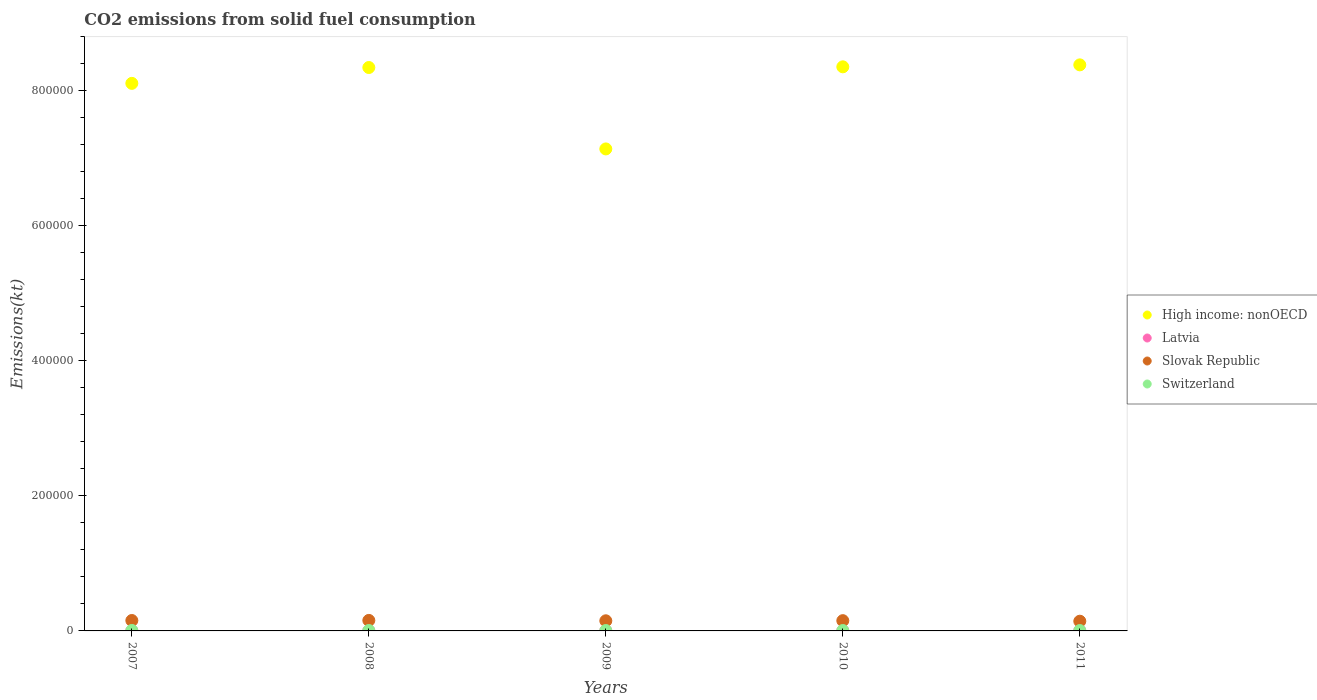What is the amount of CO2 emitted in High income: nonOECD in 2008?
Give a very brief answer. 8.35e+05. Across all years, what is the maximum amount of CO2 emitted in High income: nonOECD?
Provide a succinct answer. 8.38e+05. Across all years, what is the minimum amount of CO2 emitted in Switzerland?
Provide a succinct answer. 557.38. In which year was the amount of CO2 emitted in Latvia maximum?
Make the answer very short. 2011. What is the total amount of CO2 emitted in Latvia in the graph?
Provide a short and direct response. 2002.18. What is the difference between the amount of CO2 emitted in Slovak Republic in 2008 and that in 2009?
Ensure brevity in your answer.  568.39. What is the difference between the amount of CO2 emitted in Latvia in 2011 and the amount of CO2 emitted in Switzerland in 2010?
Make the answer very short. -139.35. What is the average amount of CO2 emitted in Switzerland per year?
Your answer should be compact. 607.26. In the year 2009, what is the difference between the amount of CO2 emitted in High income: nonOECD and amount of CO2 emitted in Switzerland?
Keep it short and to the point. 7.13e+05. What is the ratio of the amount of CO2 emitted in Switzerland in 2009 to that in 2010?
Provide a short and direct response. 0.98. Is the difference between the amount of CO2 emitted in High income: nonOECD in 2007 and 2010 greater than the difference between the amount of CO2 emitted in Switzerland in 2007 and 2010?
Ensure brevity in your answer.  No. What is the difference between the highest and the second highest amount of CO2 emitted in Switzerland?
Provide a short and direct response. 51.34. What is the difference between the highest and the lowest amount of CO2 emitted in High income: nonOECD?
Your answer should be very brief. 1.25e+05. In how many years, is the amount of CO2 emitted in Latvia greater than the average amount of CO2 emitted in Latvia taken over all years?
Offer a very short reply. 4. Is it the case that in every year, the sum of the amount of CO2 emitted in Switzerland and amount of CO2 emitted in Slovak Republic  is greater than the sum of amount of CO2 emitted in High income: nonOECD and amount of CO2 emitted in Latvia?
Your answer should be compact. Yes. Does the amount of CO2 emitted in Slovak Republic monotonically increase over the years?
Ensure brevity in your answer.  No. Is the amount of CO2 emitted in High income: nonOECD strictly greater than the amount of CO2 emitted in Slovak Republic over the years?
Make the answer very short. Yes. How many years are there in the graph?
Offer a terse response. 5. What is the difference between two consecutive major ticks on the Y-axis?
Ensure brevity in your answer.  2.00e+05. Are the values on the major ticks of Y-axis written in scientific E-notation?
Offer a terse response. No. Does the graph contain grids?
Provide a short and direct response. No. Where does the legend appear in the graph?
Your response must be concise. Center right. How many legend labels are there?
Keep it short and to the point. 4. How are the legend labels stacked?
Keep it short and to the point. Vertical. What is the title of the graph?
Keep it short and to the point. CO2 emissions from solid fuel consumption. What is the label or title of the X-axis?
Your answer should be very brief. Years. What is the label or title of the Y-axis?
Your answer should be compact. Emissions(kt). What is the Emissions(kt) of High income: nonOECD in 2007?
Provide a short and direct response. 8.11e+05. What is the Emissions(kt) of Latvia in 2007?
Ensure brevity in your answer.  407.04. What is the Emissions(kt) of Slovak Republic in 2007?
Make the answer very short. 1.54e+04. What is the Emissions(kt) of Switzerland in 2007?
Give a very brief answer. 678.39. What is the Emissions(kt) in High income: nonOECD in 2008?
Your answer should be very brief. 8.35e+05. What is the Emissions(kt) of Latvia in 2008?
Keep it short and to the point. 403.37. What is the Emissions(kt) of Slovak Republic in 2008?
Give a very brief answer. 1.56e+04. What is the Emissions(kt) of Switzerland in 2008?
Your answer should be very brief. 627.06. What is the Emissions(kt) in High income: nonOECD in 2009?
Your answer should be compact. 7.14e+05. What is the Emissions(kt) in Latvia in 2009?
Ensure brevity in your answer.  322.7. What is the Emissions(kt) of Slovak Republic in 2009?
Your response must be concise. 1.50e+04. What is the Emissions(kt) of Switzerland in 2009?
Offer a terse response. 579.39. What is the Emissions(kt) in High income: nonOECD in 2010?
Provide a succinct answer. 8.36e+05. What is the Emissions(kt) in Latvia in 2010?
Ensure brevity in your answer.  414.37. What is the Emissions(kt) of Slovak Republic in 2010?
Offer a terse response. 1.52e+04. What is the Emissions(kt) of Switzerland in 2010?
Provide a succinct answer. 594.05. What is the Emissions(kt) of High income: nonOECD in 2011?
Your answer should be compact. 8.38e+05. What is the Emissions(kt) of Latvia in 2011?
Keep it short and to the point. 454.71. What is the Emissions(kt) in Slovak Republic in 2011?
Offer a very short reply. 1.44e+04. What is the Emissions(kt) of Switzerland in 2011?
Make the answer very short. 557.38. Across all years, what is the maximum Emissions(kt) in High income: nonOECD?
Your answer should be very brief. 8.38e+05. Across all years, what is the maximum Emissions(kt) of Latvia?
Provide a short and direct response. 454.71. Across all years, what is the maximum Emissions(kt) in Slovak Republic?
Your response must be concise. 1.56e+04. Across all years, what is the maximum Emissions(kt) of Switzerland?
Ensure brevity in your answer.  678.39. Across all years, what is the minimum Emissions(kt) in High income: nonOECD?
Keep it short and to the point. 7.14e+05. Across all years, what is the minimum Emissions(kt) in Latvia?
Make the answer very short. 322.7. Across all years, what is the minimum Emissions(kt) in Slovak Republic?
Your response must be concise. 1.44e+04. Across all years, what is the minimum Emissions(kt) in Switzerland?
Offer a very short reply. 557.38. What is the total Emissions(kt) in High income: nonOECD in the graph?
Keep it short and to the point. 4.03e+06. What is the total Emissions(kt) in Latvia in the graph?
Offer a very short reply. 2002.18. What is the total Emissions(kt) in Slovak Republic in the graph?
Your answer should be very brief. 7.56e+04. What is the total Emissions(kt) in Switzerland in the graph?
Your answer should be compact. 3036.28. What is the difference between the Emissions(kt) in High income: nonOECD in 2007 and that in 2008?
Ensure brevity in your answer.  -2.35e+04. What is the difference between the Emissions(kt) in Latvia in 2007 and that in 2008?
Offer a terse response. 3.67. What is the difference between the Emissions(kt) in Slovak Republic in 2007 and that in 2008?
Provide a short and direct response. -150.35. What is the difference between the Emissions(kt) of Switzerland in 2007 and that in 2008?
Offer a terse response. 51.34. What is the difference between the Emissions(kt) of High income: nonOECD in 2007 and that in 2009?
Your response must be concise. 9.71e+04. What is the difference between the Emissions(kt) in Latvia in 2007 and that in 2009?
Offer a very short reply. 84.34. What is the difference between the Emissions(kt) in Slovak Republic in 2007 and that in 2009?
Offer a very short reply. 418.04. What is the difference between the Emissions(kt) of Switzerland in 2007 and that in 2009?
Offer a terse response. 99.01. What is the difference between the Emissions(kt) of High income: nonOECD in 2007 and that in 2010?
Your answer should be compact. -2.45e+04. What is the difference between the Emissions(kt) in Latvia in 2007 and that in 2010?
Your answer should be very brief. -7.33. What is the difference between the Emissions(kt) in Slovak Republic in 2007 and that in 2010?
Your response must be concise. 227.35. What is the difference between the Emissions(kt) of Switzerland in 2007 and that in 2010?
Ensure brevity in your answer.  84.34. What is the difference between the Emissions(kt) of High income: nonOECD in 2007 and that in 2011?
Your response must be concise. -2.74e+04. What is the difference between the Emissions(kt) of Latvia in 2007 and that in 2011?
Ensure brevity in your answer.  -47.67. What is the difference between the Emissions(kt) of Slovak Republic in 2007 and that in 2011?
Give a very brief answer. 1037.76. What is the difference between the Emissions(kt) in Switzerland in 2007 and that in 2011?
Give a very brief answer. 121.01. What is the difference between the Emissions(kt) in High income: nonOECD in 2008 and that in 2009?
Ensure brevity in your answer.  1.21e+05. What is the difference between the Emissions(kt) in Latvia in 2008 and that in 2009?
Provide a succinct answer. 80.67. What is the difference between the Emissions(kt) in Slovak Republic in 2008 and that in 2009?
Provide a short and direct response. 568.38. What is the difference between the Emissions(kt) in Switzerland in 2008 and that in 2009?
Your answer should be very brief. 47.67. What is the difference between the Emissions(kt) in High income: nonOECD in 2008 and that in 2010?
Your response must be concise. -1015.26. What is the difference between the Emissions(kt) of Latvia in 2008 and that in 2010?
Your answer should be compact. -11. What is the difference between the Emissions(kt) of Slovak Republic in 2008 and that in 2010?
Your answer should be very brief. 377.7. What is the difference between the Emissions(kt) of Switzerland in 2008 and that in 2010?
Provide a succinct answer. 33. What is the difference between the Emissions(kt) of High income: nonOECD in 2008 and that in 2011?
Your answer should be compact. -3916.7. What is the difference between the Emissions(kt) in Latvia in 2008 and that in 2011?
Your response must be concise. -51.34. What is the difference between the Emissions(kt) of Slovak Republic in 2008 and that in 2011?
Ensure brevity in your answer.  1188.11. What is the difference between the Emissions(kt) in Switzerland in 2008 and that in 2011?
Your answer should be very brief. 69.67. What is the difference between the Emissions(kt) of High income: nonOECD in 2009 and that in 2010?
Make the answer very short. -1.22e+05. What is the difference between the Emissions(kt) in Latvia in 2009 and that in 2010?
Make the answer very short. -91.67. What is the difference between the Emissions(kt) in Slovak Republic in 2009 and that in 2010?
Your answer should be compact. -190.68. What is the difference between the Emissions(kt) of Switzerland in 2009 and that in 2010?
Your answer should be compact. -14.67. What is the difference between the Emissions(kt) of High income: nonOECD in 2009 and that in 2011?
Offer a terse response. -1.25e+05. What is the difference between the Emissions(kt) in Latvia in 2009 and that in 2011?
Offer a very short reply. -132.01. What is the difference between the Emissions(kt) of Slovak Republic in 2009 and that in 2011?
Ensure brevity in your answer.  619.72. What is the difference between the Emissions(kt) of Switzerland in 2009 and that in 2011?
Keep it short and to the point. 22. What is the difference between the Emissions(kt) of High income: nonOECD in 2010 and that in 2011?
Your answer should be very brief. -2901.44. What is the difference between the Emissions(kt) in Latvia in 2010 and that in 2011?
Your answer should be compact. -40.34. What is the difference between the Emissions(kt) of Slovak Republic in 2010 and that in 2011?
Make the answer very short. 810.41. What is the difference between the Emissions(kt) of Switzerland in 2010 and that in 2011?
Keep it short and to the point. 36.67. What is the difference between the Emissions(kt) of High income: nonOECD in 2007 and the Emissions(kt) of Latvia in 2008?
Offer a very short reply. 8.11e+05. What is the difference between the Emissions(kt) in High income: nonOECD in 2007 and the Emissions(kt) in Slovak Republic in 2008?
Provide a short and direct response. 7.95e+05. What is the difference between the Emissions(kt) in High income: nonOECD in 2007 and the Emissions(kt) in Switzerland in 2008?
Provide a short and direct response. 8.10e+05. What is the difference between the Emissions(kt) of Latvia in 2007 and the Emissions(kt) of Slovak Republic in 2008?
Your response must be concise. -1.52e+04. What is the difference between the Emissions(kt) in Latvia in 2007 and the Emissions(kt) in Switzerland in 2008?
Keep it short and to the point. -220.02. What is the difference between the Emissions(kt) of Slovak Republic in 2007 and the Emissions(kt) of Switzerland in 2008?
Your answer should be compact. 1.48e+04. What is the difference between the Emissions(kt) in High income: nonOECD in 2007 and the Emissions(kt) in Latvia in 2009?
Ensure brevity in your answer.  8.11e+05. What is the difference between the Emissions(kt) of High income: nonOECD in 2007 and the Emissions(kt) of Slovak Republic in 2009?
Keep it short and to the point. 7.96e+05. What is the difference between the Emissions(kt) of High income: nonOECD in 2007 and the Emissions(kt) of Switzerland in 2009?
Your answer should be compact. 8.10e+05. What is the difference between the Emissions(kt) of Latvia in 2007 and the Emissions(kt) of Slovak Republic in 2009?
Provide a short and direct response. -1.46e+04. What is the difference between the Emissions(kt) of Latvia in 2007 and the Emissions(kt) of Switzerland in 2009?
Give a very brief answer. -172.35. What is the difference between the Emissions(kt) in Slovak Republic in 2007 and the Emissions(kt) in Switzerland in 2009?
Ensure brevity in your answer.  1.48e+04. What is the difference between the Emissions(kt) in High income: nonOECD in 2007 and the Emissions(kt) in Latvia in 2010?
Your answer should be compact. 8.11e+05. What is the difference between the Emissions(kt) in High income: nonOECD in 2007 and the Emissions(kt) in Slovak Republic in 2010?
Offer a terse response. 7.96e+05. What is the difference between the Emissions(kt) of High income: nonOECD in 2007 and the Emissions(kt) of Switzerland in 2010?
Offer a terse response. 8.10e+05. What is the difference between the Emissions(kt) of Latvia in 2007 and the Emissions(kt) of Slovak Republic in 2010?
Offer a very short reply. -1.48e+04. What is the difference between the Emissions(kt) of Latvia in 2007 and the Emissions(kt) of Switzerland in 2010?
Give a very brief answer. -187.02. What is the difference between the Emissions(kt) in Slovak Republic in 2007 and the Emissions(kt) in Switzerland in 2010?
Make the answer very short. 1.48e+04. What is the difference between the Emissions(kt) of High income: nonOECD in 2007 and the Emissions(kt) of Latvia in 2011?
Ensure brevity in your answer.  8.11e+05. What is the difference between the Emissions(kt) in High income: nonOECD in 2007 and the Emissions(kt) in Slovak Republic in 2011?
Keep it short and to the point. 7.97e+05. What is the difference between the Emissions(kt) of High income: nonOECD in 2007 and the Emissions(kt) of Switzerland in 2011?
Your answer should be compact. 8.10e+05. What is the difference between the Emissions(kt) of Latvia in 2007 and the Emissions(kt) of Slovak Republic in 2011?
Make the answer very short. -1.40e+04. What is the difference between the Emissions(kt) in Latvia in 2007 and the Emissions(kt) in Switzerland in 2011?
Keep it short and to the point. -150.35. What is the difference between the Emissions(kt) of Slovak Republic in 2007 and the Emissions(kt) of Switzerland in 2011?
Your answer should be very brief. 1.49e+04. What is the difference between the Emissions(kt) in High income: nonOECD in 2008 and the Emissions(kt) in Latvia in 2009?
Provide a succinct answer. 8.34e+05. What is the difference between the Emissions(kt) of High income: nonOECD in 2008 and the Emissions(kt) of Slovak Republic in 2009?
Provide a succinct answer. 8.20e+05. What is the difference between the Emissions(kt) of High income: nonOECD in 2008 and the Emissions(kt) of Switzerland in 2009?
Offer a terse response. 8.34e+05. What is the difference between the Emissions(kt) in Latvia in 2008 and the Emissions(kt) in Slovak Republic in 2009?
Give a very brief answer. -1.46e+04. What is the difference between the Emissions(kt) in Latvia in 2008 and the Emissions(kt) in Switzerland in 2009?
Your response must be concise. -176.02. What is the difference between the Emissions(kt) of Slovak Republic in 2008 and the Emissions(kt) of Switzerland in 2009?
Give a very brief answer. 1.50e+04. What is the difference between the Emissions(kt) of High income: nonOECD in 2008 and the Emissions(kt) of Latvia in 2010?
Provide a short and direct response. 8.34e+05. What is the difference between the Emissions(kt) of High income: nonOECD in 2008 and the Emissions(kt) of Slovak Republic in 2010?
Your response must be concise. 8.19e+05. What is the difference between the Emissions(kt) of High income: nonOECD in 2008 and the Emissions(kt) of Switzerland in 2010?
Give a very brief answer. 8.34e+05. What is the difference between the Emissions(kt) of Latvia in 2008 and the Emissions(kt) of Slovak Republic in 2010?
Keep it short and to the point. -1.48e+04. What is the difference between the Emissions(kt) of Latvia in 2008 and the Emissions(kt) of Switzerland in 2010?
Provide a short and direct response. -190.68. What is the difference between the Emissions(kt) of Slovak Republic in 2008 and the Emissions(kt) of Switzerland in 2010?
Keep it short and to the point. 1.50e+04. What is the difference between the Emissions(kt) in High income: nonOECD in 2008 and the Emissions(kt) in Latvia in 2011?
Your response must be concise. 8.34e+05. What is the difference between the Emissions(kt) in High income: nonOECD in 2008 and the Emissions(kt) in Slovak Republic in 2011?
Make the answer very short. 8.20e+05. What is the difference between the Emissions(kt) in High income: nonOECD in 2008 and the Emissions(kt) in Switzerland in 2011?
Your answer should be very brief. 8.34e+05. What is the difference between the Emissions(kt) in Latvia in 2008 and the Emissions(kt) in Slovak Republic in 2011?
Give a very brief answer. -1.40e+04. What is the difference between the Emissions(kt) of Latvia in 2008 and the Emissions(kt) of Switzerland in 2011?
Give a very brief answer. -154.01. What is the difference between the Emissions(kt) in Slovak Republic in 2008 and the Emissions(kt) in Switzerland in 2011?
Provide a succinct answer. 1.50e+04. What is the difference between the Emissions(kt) in High income: nonOECD in 2009 and the Emissions(kt) in Latvia in 2010?
Your response must be concise. 7.14e+05. What is the difference between the Emissions(kt) of High income: nonOECD in 2009 and the Emissions(kt) of Slovak Republic in 2010?
Give a very brief answer. 6.99e+05. What is the difference between the Emissions(kt) in High income: nonOECD in 2009 and the Emissions(kt) in Switzerland in 2010?
Provide a short and direct response. 7.13e+05. What is the difference between the Emissions(kt) of Latvia in 2009 and the Emissions(kt) of Slovak Republic in 2010?
Your response must be concise. -1.49e+04. What is the difference between the Emissions(kt) of Latvia in 2009 and the Emissions(kt) of Switzerland in 2010?
Provide a short and direct response. -271.36. What is the difference between the Emissions(kt) of Slovak Republic in 2009 and the Emissions(kt) of Switzerland in 2010?
Make the answer very short. 1.44e+04. What is the difference between the Emissions(kt) in High income: nonOECD in 2009 and the Emissions(kt) in Latvia in 2011?
Your response must be concise. 7.13e+05. What is the difference between the Emissions(kt) of High income: nonOECD in 2009 and the Emissions(kt) of Slovak Republic in 2011?
Keep it short and to the point. 7.00e+05. What is the difference between the Emissions(kt) of High income: nonOECD in 2009 and the Emissions(kt) of Switzerland in 2011?
Provide a short and direct response. 7.13e+05. What is the difference between the Emissions(kt) in Latvia in 2009 and the Emissions(kt) in Slovak Republic in 2011?
Your answer should be compact. -1.41e+04. What is the difference between the Emissions(kt) in Latvia in 2009 and the Emissions(kt) in Switzerland in 2011?
Your response must be concise. -234.69. What is the difference between the Emissions(kt) in Slovak Republic in 2009 and the Emissions(kt) in Switzerland in 2011?
Your response must be concise. 1.44e+04. What is the difference between the Emissions(kt) of High income: nonOECD in 2010 and the Emissions(kt) of Latvia in 2011?
Give a very brief answer. 8.35e+05. What is the difference between the Emissions(kt) in High income: nonOECD in 2010 and the Emissions(kt) in Slovak Republic in 2011?
Make the answer very short. 8.21e+05. What is the difference between the Emissions(kt) of High income: nonOECD in 2010 and the Emissions(kt) of Switzerland in 2011?
Your answer should be compact. 8.35e+05. What is the difference between the Emissions(kt) of Latvia in 2010 and the Emissions(kt) of Slovak Republic in 2011?
Make the answer very short. -1.40e+04. What is the difference between the Emissions(kt) of Latvia in 2010 and the Emissions(kt) of Switzerland in 2011?
Give a very brief answer. -143.01. What is the difference between the Emissions(kt) of Slovak Republic in 2010 and the Emissions(kt) of Switzerland in 2011?
Give a very brief answer. 1.46e+04. What is the average Emissions(kt) of High income: nonOECD per year?
Make the answer very short. 8.07e+05. What is the average Emissions(kt) in Latvia per year?
Give a very brief answer. 400.44. What is the average Emissions(kt) in Slovak Republic per year?
Offer a terse response. 1.51e+04. What is the average Emissions(kt) of Switzerland per year?
Your answer should be compact. 607.26. In the year 2007, what is the difference between the Emissions(kt) of High income: nonOECD and Emissions(kt) of Latvia?
Give a very brief answer. 8.11e+05. In the year 2007, what is the difference between the Emissions(kt) in High income: nonOECD and Emissions(kt) in Slovak Republic?
Ensure brevity in your answer.  7.96e+05. In the year 2007, what is the difference between the Emissions(kt) in High income: nonOECD and Emissions(kt) in Switzerland?
Offer a very short reply. 8.10e+05. In the year 2007, what is the difference between the Emissions(kt) in Latvia and Emissions(kt) in Slovak Republic?
Make the answer very short. -1.50e+04. In the year 2007, what is the difference between the Emissions(kt) of Latvia and Emissions(kt) of Switzerland?
Ensure brevity in your answer.  -271.36. In the year 2007, what is the difference between the Emissions(kt) of Slovak Republic and Emissions(kt) of Switzerland?
Keep it short and to the point. 1.47e+04. In the year 2008, what is the difference between the Emissions(kt) of High income: nonOECD and Emissions(kt) of Latvia?
Offer a very short reply. 8.34e+05. In the year 2008, what is the difference between the Emissions(kt) in High income: nonOECD and Emissions(kt) in Slovak Republic?
Keep it short and to the point. 8.19e+05. In the year 2008, what is the difference between the Emissions(kt) in High income: nonOECD and Emissions(kt) in Switzerland?
Give a very brief answer. 8.34e+05. In the year 2008, what is the difference between the Emissions(kt) of Latvia and Emissions(kt) of Slovak Republic?
Your answer should be compact. -1.52e+04. In the year 2008, what is the difference between the Emissions(kt) in Latvia and Emissions(kt) in Switzerland?
Offer a very short reply. -223.69. In the year 2008, what is the difference between the Emissions(kt) in Slovak Republic and Emissions(kt) in Switzerland?
Keep it short and to the point. 1.49e+04. In the year 2009, what is the difference between the Emissions(kt) of High income: nonOECD and Emissions(kt) of Latvia?
Make the answer very short. 7.14e+05. In the year 2009, what is the difference between the Emissions(kt) of High income: nonOECD and Emissions(kt) of Slovak Republic?
Provide a succinct answer. 6.99e+05. In the year 2009, what is the difference between the Emissions(kt) in High income: nonOECD and Emissions(kt) in Switzerland?
Give a very brief answer. 7.13e+05. In the year 2009, what is the difference between the Emissions(kt) of Latvia and Emissions(kt) of Slovak Republic?
Give a very brief answer. -1.47e+04. In the year 2009, what is the difference between the Emissions(kt) in Latvia and Emissions(kt) in Switzerland?
Your response must be concise. -256.69. In the year 2009, what is the difference between the Emissions(kt) of Slovak Republic and Emissions(kt) of Switzerland?
Make the answer very short. 1.44e+04. In the year 2010, what is the difference between the Emissions(kt) of High income: nonOECD and Emissions(kt) of Latvia?
Keep it short and to the point. 8.35e+05. In the year 2010, what is the difference between the Emissions(kt) of High income: nonOECD and Emissions(kt) of Slovak Republic?
Your answer should be compact. 8.20e+05. In the year 2010, what is the difference between the Emissions(kt) of High income: nonOECD and Emissions(kt) of Switzerland?
Provide a short and direct response. 8.35e+05. In the year 2010, what is the difference between the Emissions(kt) of Latvia and Emissions(kt) of Slovak Republic?
Your response must be concise. -1.48e+04. In the year 2010, what is the difference between the Emissions(kt) of Latvia and Emissions(kt) of Switzerland?
Give a very brief answer. -179.68. In the year 2010, what is the difference between the Emissions(kt) of Slovak Republic and Emissions(kt) of Switzerland?
Your answer should be compact. 1.46e+04. In the year 2011, what is the difference between the Emissions(kt) of High income: nonOECD and Emissions(kt) of Latvia?
Provide a succinct answer. 8.38e+05. In the year 2011, what is the difference between the Emissions(kt) in High income: nonOECD and Emissions(kt) in Slovak Republic?
Give a very brief answer. 8.24e+05. In the year 2011, what is the difference between the Emissions(kt) in High income: nonOECD and Emissions(kt) in Switzerland?
Give a very brief answer. 8.38e+05. In the year 2011, what is the difference between the Emissions(kt) in Latvia and Emissions(kt) in Slovak Republic?
Provide a succinct answer. -1.39e+04. In the year 2011, what is the difference between the Emissions(kt) of Latvia and Emissions(kt) of Switzerland?
Offer a terse response. -102.68. In the year 2011, what is the difference between the Emissions(kt) in Slovak Republic and Emissions(kt) in Switzerland?
Provide a short and direct response. 1.38e+04. What is the ratio of the Emissions(kt) in High income: nonOECD in 2007 to that in 2008?
Make the answer very short. 0.97. What is the ratio of the Emissions(kt) in Latvia in 2007 to that in 2008?
Offer a very short reply. 1.01. What is the ratio of the Emissions(kt) of Slovak Republic in 2007 to that in 2008?
Ensure brevity in your answer.  0.99. What is the ratio of the Emissions(kt) in Switzerland in 2007 to that in 2008?
Give a very brief answer. 1.08. What is the ratio of the Emissions(kt) of High income: nonOECD in 2007 to that in 2009?
Your answer should be compact. 1.14. What is the ratio of the Emissions(kt) of Latvia in 2007 to that in 2009?
Offer a very short reply. 1.26. What is the ratio of the Emissions(kt) of Slovak Republic in 2007 to that in 2009?
Keep it short and to the point. 1.03. What is the ratio of the Emissions(kt) in Switzerland in 2007 to that in 2009?
Provide a short and direct response. 1.17. What is the ratio of the Emissions(kt) in High income: nonOECD in 2007 to that in 2010?
Offer a very short reply. 0.97. What is the ratio of the Emissions(kt) in Latvia in 2007 to that in 2010?
Give a very brief answer. 0.98. What is the ratio of the Emissions(kt) in Slovak Republic in 2007 to that in 2010?
Provide a succinct answer. 1.01. What is the ratio of the Emissions(kt) of Switzerland in 2007 to that in 2010?
Make the answer very short. 1.14. What is the ratio of the Emissions(kt) in High income: nonOECD in 2007 to that in 2011?
Offer a terse response. 0.97. What is the ratio of the Emissions(kt) of Latvia in 2007 to that in 2011?
Ensure brevity in your answer.  0.9. What is the ratio of the Emissions(kt) in Slovak Republic in 2007 to that in 2011?
Your response must be concise. 1.07. What is the ratio of the Emissions(kt) in Switzerland in 2007 to that in 2011?
Offer a terse response. 1.22. What is the ratio of the Emissions(kt) in High income: nonOECD in 2008 to that in 2009?
Give a very brief answer. 1.17. What is the ratio of the Emissions(kt) in Slovak Republic in 2008 to that in 2009?
Keep it short and to the point. 1.04. What is the ratio of the Emissions(kt) of Switzerland in 2008 to that in 2009?
Keep it short and to the point. 1.08. What is the ratio of the Emissions(kt) in High income: nonOECD in 2008 to that in 2010?
Provide a short and direct response. 1. What is the ratio of the Emissions(kt) in Latvia in 2008 to that in 2010?
Provide a short and direct response. 0.97. What is the ratio of the Emissions(kt) of Slovak Republic in 2008 to that in 2010?
Your answer should be compact. 1.02. What is the ratio of the Emissions(kt) in Switzerland in 2008 to that in 2010?
Keep it short and to the point. 1.06. What is the ratio of the Emissions(kt) of Latvia in 2008 to that in 2011?
Make the answer very short. 0.89. What is the ratio of the Emissions(kt) of Slovak Republic in 2008 to that in 2011?
Your response must be concise. 1.08. What is the ratio of the Emissions(kt) of High income: nonOECD in 2009 to that in 2010?
Your response must be concise. 0.85. What is the ratio of the Emissions(kt) of Latvia in 2009 to that in 2010?
Your answer should be compact. 0.78. What is the ratio of the Emissions(kt) of Slovak Republic in 2009 to that in 2010?
Ensure brevity in your answer.  0.99. What is the ratio of the Emissions(kt) in Switzerland in 2009 to that in 2010?
Provide a short and direct response. 0.98. What is the ratio of the Emissions(kt) of High income: nonOECD in 2009 to that in 2011?
Your response must be concise. 0.85. What is the ratio of the Emissions(kt) of Latvia in 2009 to that in 2011?
Offer a very short reply. 0.71. What is the ratio of the Emissions(kt) in Slovak Republic in 2009 to that in 2011?
Offer a terse response. 1.04. What is the ratio of the Emissions(kt) of Switzerland in 2009 to that in 2011?
Ensure brevity in your answer.  1.04. What is the ratio of the Emissions(kt) in Latvia in 2010 to that in 2011?
Your answer should be very brief. 0.91. What is the ratio of the Emissions(kt) of Slovak Republic in 2010 to that in 2011?
Ensure brevity in your answer.  1.06. What is the ratio of the Emissions(kt) in Switzerland in 2010 to that in 2011?
Keep it short and to the point. 1.07. What is the difference between the highest and the second highest Emissions(kt) of High income: nonOECD?
Keep it short and to the point. 2901.44. What is the difference between the highest and the second highest Emissions(kt) in Latvia?
Ensure brevity in your answer.  40.34. What is the difference between the highest and the second highest Emissions(kt) of Slovak Republic?
Provide a short and direct response. 150.35. What is the difference between the highest and the second highest Emissions(kt) of Switzerland?
Keep it short and to the point. 51.34. What is the difference between the highest and the lowest Emissions(kt) of High income: nonOECD?
Your answer should be compact. 1.25e+05. What is the difference between the highest and the lowest Emissions(kt) of Latvia?
Provide a short and direct response. 132.01. What is the difference between the highest and the lowest Emissions(kt) of Slovak Republic?
Your answer should be compact. 1188.11. What is the difference between the highest and the lowest Emissions(kt) in Switzerland?
Offer a very short reply. 121.01. 